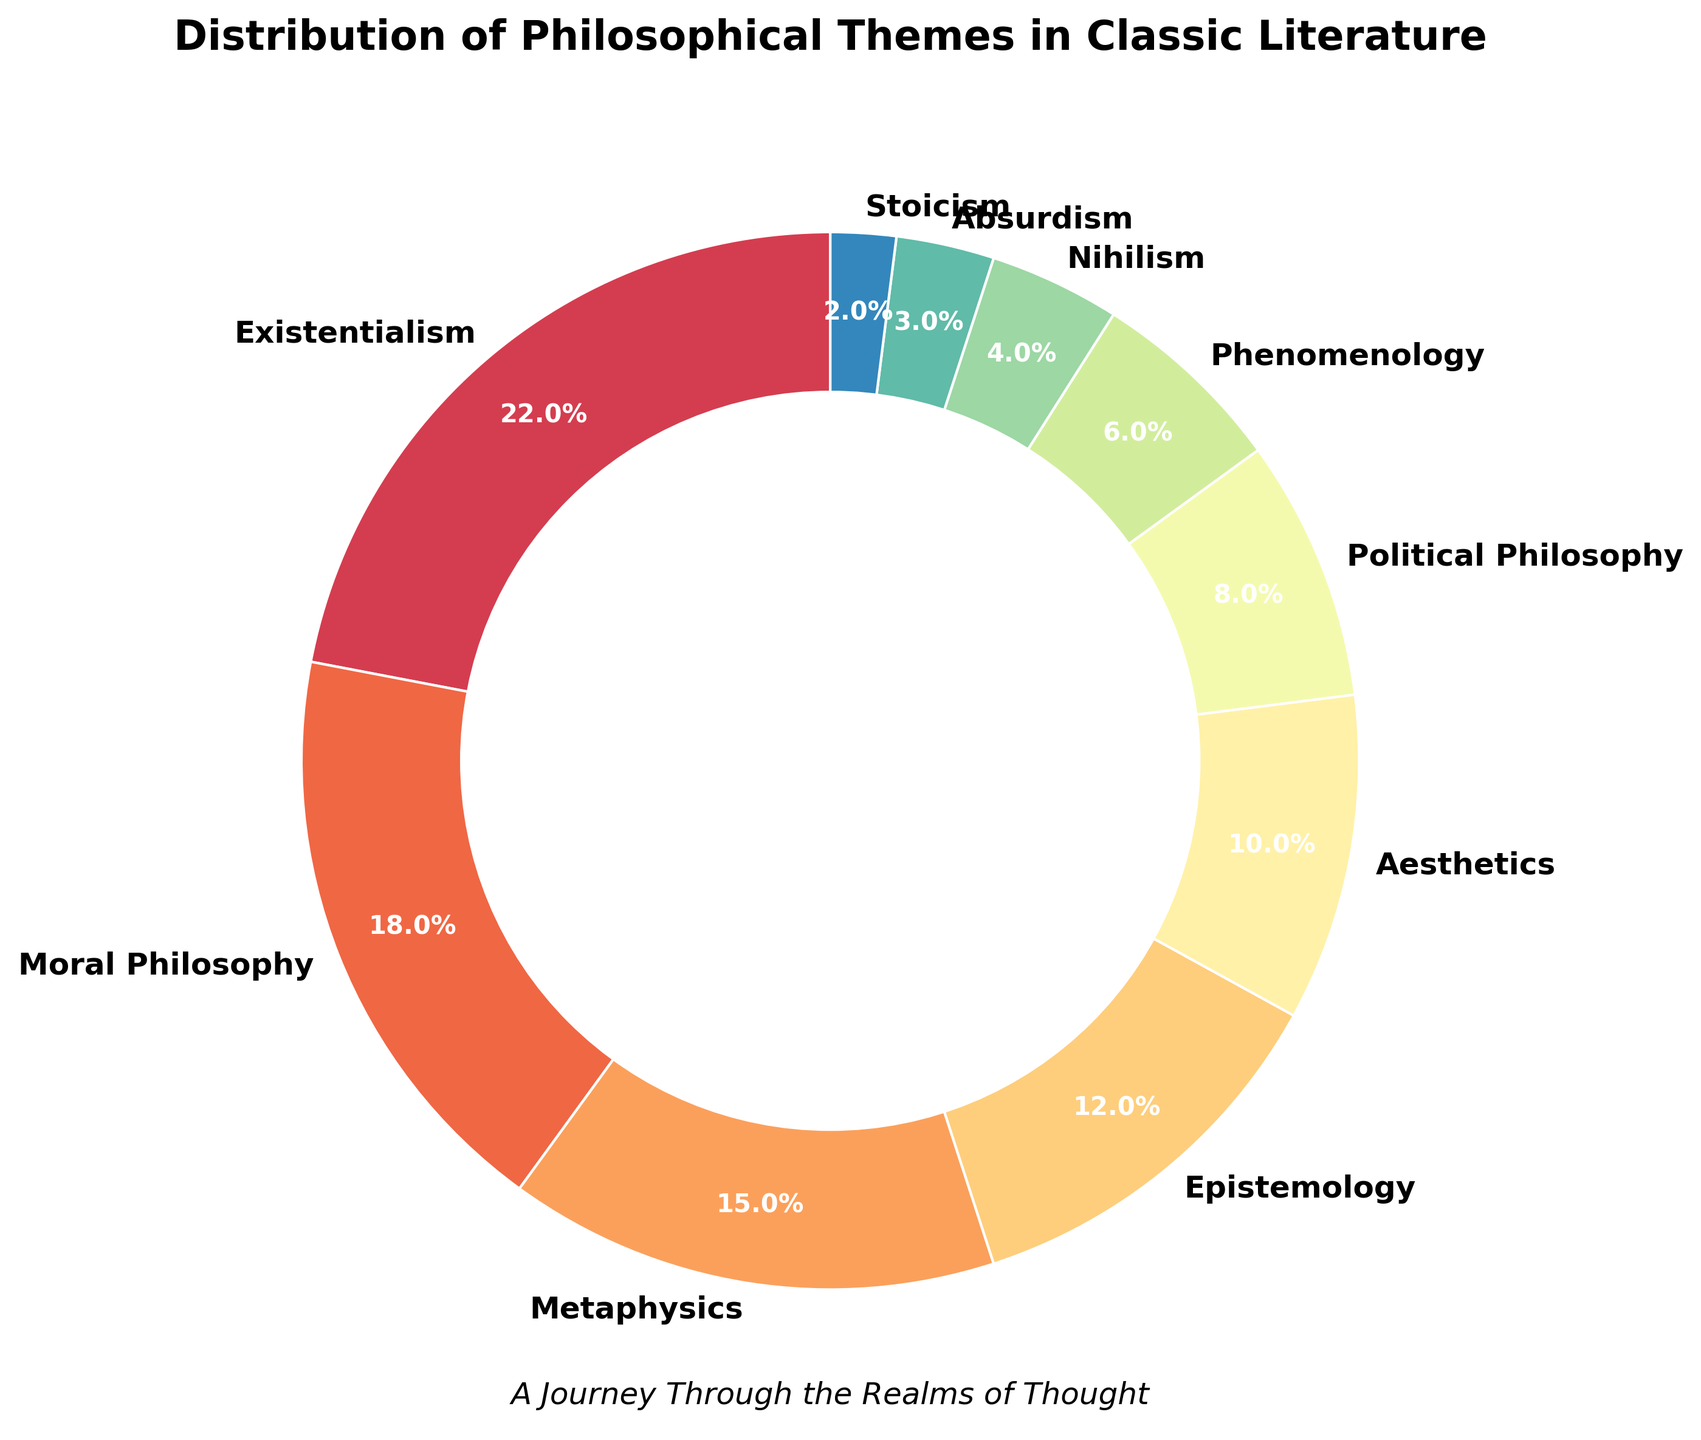What percentage of themes in classic literature is covered by Metaphysics and Nihilism combined? First, locate the percentage for Metaphysics (15%) and Nihilism (4%). Add these percentages together: 15% + 4% = 19%.
Answer: 19% Which theme has a higher percentage: Epistemology or Aesthetics? Locate both the percentages for Epistemology (12%) and Aesthetics (10%). Compare the two values: 12% > 10%. Hence, Epistemology has a higher percentage.
Answer: Epistemology What is the combined percentage for the least represented three themes? Identify the three themes with the smallest percentages: Stoicism (2%), Absurdism (3%), and Nihilism (4%). Sum these percentages: 2% + 3% + 4% = 9%.
Answer: 9% Is Existentialism more prevalent than the combined percentage of Phenomenology and Political Philosophy? First, find the percentage for Existentialism (22%). Add the percentages for Phenomenology (6%) and Political Philosophy (8%): 6% + 8% = 14%. Compare the values: 22% > 14%.
Answer: Yes Which theme occupies the largest section of the pie chart and how do you know this? Observe the pie chart to identify the theme with the largest wedge. Existentialism, with 22%, appears as the most prominent section.
Answer: Existentialism By how much does Moral Philosophy exceed Political Philosophy in terms of percentage? Find the percentages for Moral Philosophy (18%) and Political Philosophy (8%). Subtract the percentage of Political Philosophy from Moral Philosophy: 18% - 8% = 10%.
Answer: 10% Name three middle-ranking themes based on their percentages and arrange them in descending order. Identify the themes that are neither the highest nor the lowest: Metaphysics (15%), Epistemology (12%), Aesthetics (10%). Arrange them from highest to lowest: Metaphysics, Epistemology, Aesthetics.
Answer: Metaphysics, Epistemology, Aesthetics Which theme is least represented in classic literature and what is its percentage? Observe the smallest wedge in the pie chart, which corresponds to Stoicism. The percentage for Stoicism is 2%.
Answer: Stoicism, 2% What percentage of themes does Absurdism cover compared to Aesthetics? Determine the percentages for Absurdism (3%) and Aesthetics (10%). Compare them using a fraction: 3% / 10% = 0.3, meaning Absurdism is 30% of the Aesthetics percentage.
Answer: 30% How does the sum of Existentialism and Moral Philosophy compare to the sum of Metaphysics and Epistemology? First, add the percentages for Existentialism (22%) and Moral Philosophy (18%): 22% + 18% = 40%. Then, add the percentages for Metaphysics (15%) and Epistemology (12%): 15% + 12% = 27%. Compare the sums: 40% > 27%.
Answer: Existentialism and Moral Philosophy have a higher combined percentage 